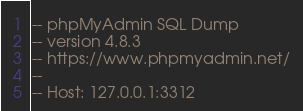Convert code to text. <code><loc_0><loc_0><loc_500><loc_500><_SQL_>-- phpMyAdmin SQL Dump
-- version 4.8.3
-- https://www.phpmyadmin.net/
--
-- Host: 127.0.0.1:3312</code> 